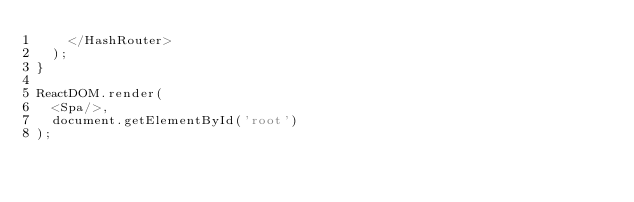<code> <loc_0><loc_0><loc_500><loc_500><_JavaScript_>    </HashRouter>
  );
}

ReactDOM.render(
  <Spa/>,
  document.getElementById('root')
);
</code> 